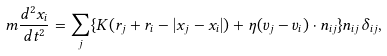<formula> <loc_0><loc_0><loc_500><loc_500>m \frac { d ^ { 2 } { x } _ { i } } { d t ^ { 2 } } = \sum _ { j } \{ K ( r _ { j } + r _ { i } - | { x } _ { j } - { x } _ { i } | ) + \eta ( { v } _ { j } - { v } _ { i } ) \cdot { n } _ { i j } \} { n } _ { i j } \delta _ { i j } ,</formula> 